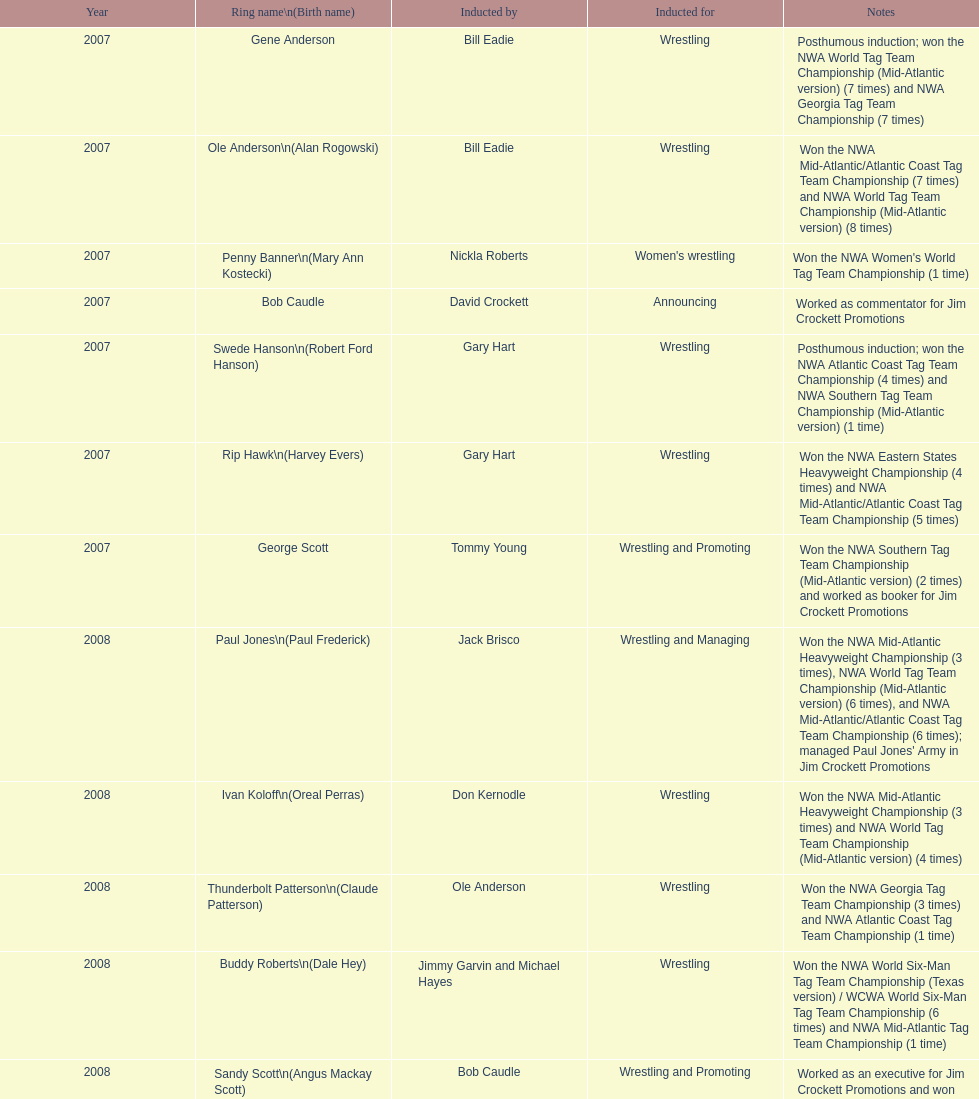Who was another announcer besides bob caudle? Lance Russell. 